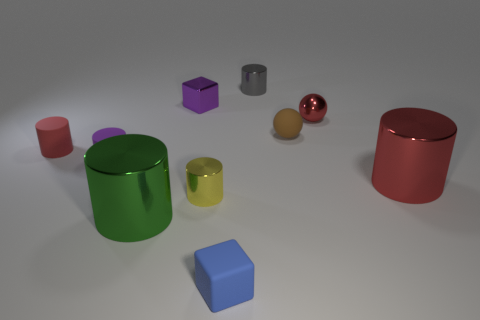Subtract all small yellow shiny cylinders. How many cylinders are left? 5 Subtract all brown balls. How many balls are left? 1 Subtract 2 blocks. How many blocks are left? 0 Subtract all blue balls. Subtract all yellow blocks. How many balls are left? 2 Subtract all cyan balls. How many red cylinders are left? 2 Subtract all small brown spheres. Subtract all big cylinders. How many objects are left? 7 Add 3 tiny blue rubber things. How many tiny blue rubber things are left? 4 Add 2 large red metallic cylinders. How many large red metallic cylinders exist? 3 Subtract 0 yellow balls. How many objects are left? 10 Subtract all blocks. How many objects are left? 8 